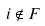<formula> <loc_0><loc_0><loc_500><loc_500>i \notin F</formula> 